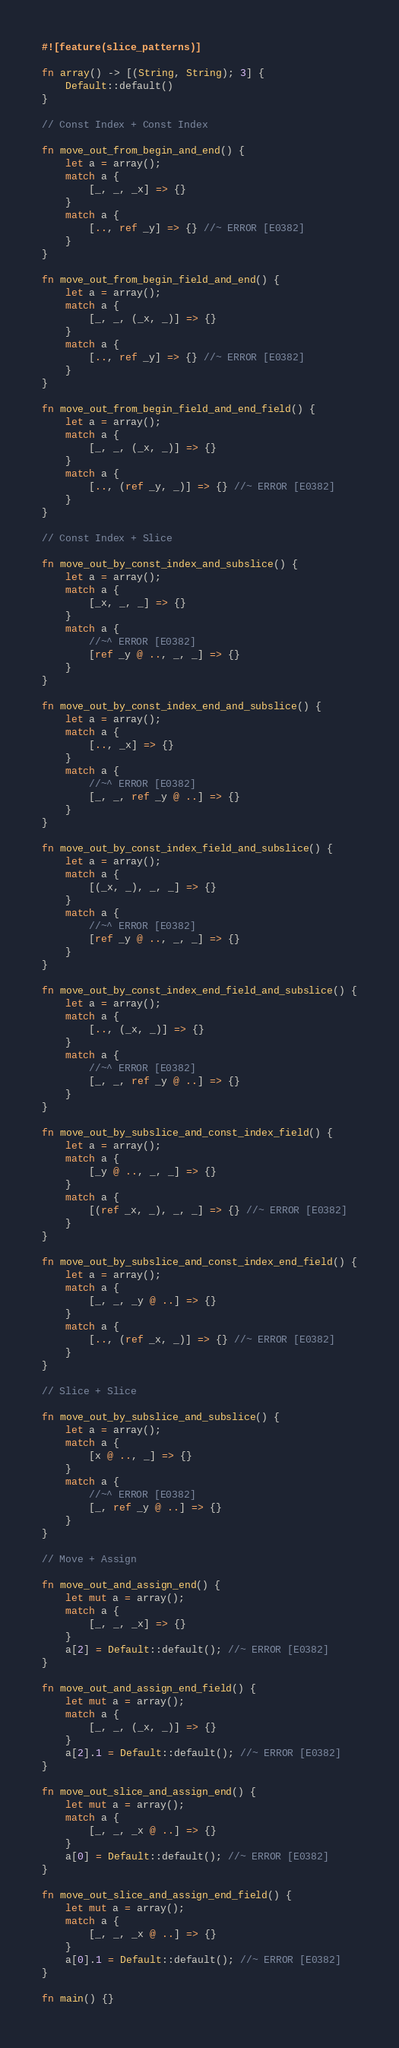<code> <loc_0><loc_0><loc_500><loc_500><_Rust_>#![feature(slice_patterns)]

fn array() -> [(String, String); 3] {
    Default::default()
}

// Const Index + Const Index

fn move_out_from_begin_and_end() {
    let a = array();
    match a {
        [_, _, _x] => {}
    }
    match a {
        [.., ref _y] => {} //~ ERROR [E0382]
    }
}

fn move_out_from_begin_field_and_end() {
    let a = array();
    match a {
        [_, _, (_x, _)] => {}
    }
    match a {
        [.., ref _y] => {} //~ ERROR [E0382]
    }
}

fn move_out_from_begin_field_and_end_field() {
    let a = array();
    match a {
        [_, _, (_x, _)] => {}
    }
    match a {
        [.., (ref _y, _)] => {} //~ ERROR [E0382]
    }
}

// Const Index + Slice

fn move_out_by_const_index_and_subslice() {
    let a = array();
    match a {
        [_x, _, _] => {}
    }
    match a {
        //~^ ERROR [E0382]
        [ref _y @ .., _, _] => {}
    }
}

fn move_out_by_const_index_end_and_subslice() {
    let a = array();
    match a {
        [.., _x] => {}
    }
    match a {
        //~^ ERROR [E0382]
        [_, _, ref _y @ ..] => {}
    }
}

fn move_out_by_const_index_field_and_subslice() {
    let a = array();
    match a {
        [(_x, _), _, _] => {}
    }
    match a {
        //~^ ERROR [E0382]
        [ref _y @ .., _, _] => {}
    }
}

fn move_out_by_const_index_end_field_and_subslice() {
    let a = array();
    match a {
        [.., (_x, _)] => {}
    }
    match a {
        //~^ ERROR [E0382]
        [_, _, ref _y @ ..] => {}
    }
}

fn move_out_by_subslice_and_const_index_field() {
    let a = array();
    match a {
        [_y @ .., _, _] => {}
    }
    match a {
        [(ref _x, _), _, _] => {} //~ ERROR [E0382]
    }
}

fn move_out_by_subslice_and_const_index_end_field() {
    let a = array();
    match a {
        [_, _, _y @ ..] => {}
    }
    match a {
        [.., (ref _x, _)] => {} //~ ERROR [E0382]
    }
}

// Slice + Slice

fn move_out_by_subslice_and_subslice() {
    let a = array();
    match a {
        [x @ .., _] => {}
    }
    match a {
        //~^ ERROR [E0382]
        [_, ref _y @ ..] => {}
    }
}

// Move + Assign

fn move_out_and_assign_end() {
    let mut a = array();
    match a {
        [_, _, _x] => {}
    }
    a[2] = Default::default(); //~ ERROR [E0382]
}

fn move_out_and_assign_end_field() {
    let mut a = array();
    match a {
        [_, _, (_x, _)] => {}
    }
    a[2].1 = Default::default(); //~ ERROR [E0382]
}

fn move_out_slice_and_assign_end() {
    let mut a = array();
    match a {
        [_, _, _x @ ..] => {}
    }
    a[0] = Default::default(); //~ ERROR [E0382]
}

fn move_out_slice_and_assign_end_field() {
    let mut a = array();
    match a {
        [_, _, _x @ ..] => {}
    }
    a[0].1 = Default::default(); //~ ERROR [E0382]
}

fn main() {}
</code> 